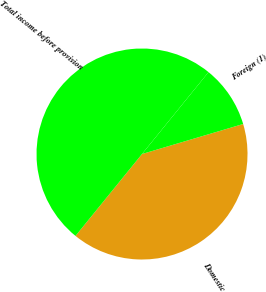Convert chart. <chart><loc_0><loc_0><loc_500><loc_500><pie_chart><fcel>Domestic<fcel>Foreign (1)<fcel>Total income before provision<nl><fcel>40.45%<fcel>9.55%<fcel>50.0%<nl></chart> 